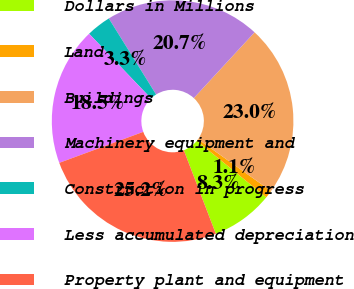Convert chart to OTSL. <chart><loc_0><loc_0><loc_500><loc_500><pie_chart><fcel>Dollars in Millions<fcel>Land<fcel>Buildings<fcel>Machinery equipment and<fcel>Construction in progress<fcel>Less accumulated depreciation<fcel>Property plant and equipment<nl><fcel>8.29%<fcel>1.05%<fcel>22.96%<fcel>20.72%<fcel>3.29%<fcel>18.48%<fcel>25.2%<nl></chart> 